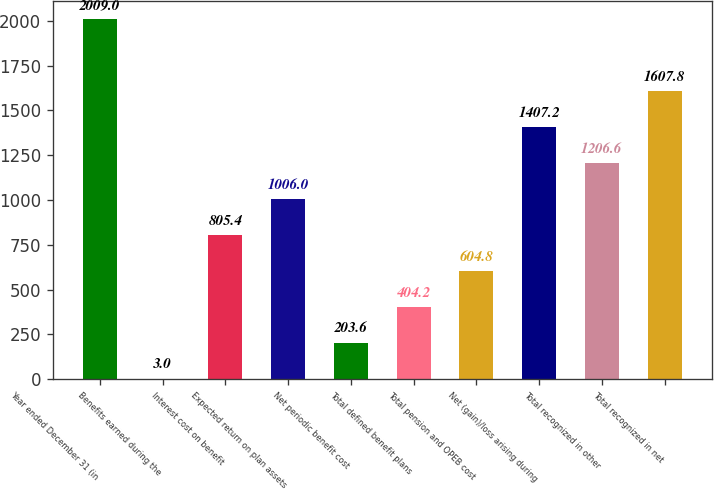Convert chart. <chart><loc_0><loc_0><loc_500><loc_500><bar_chart><fcel>Year ended December 31 (in<fcel>Benefits earned during the<fcel>Interest cost on benefit<fcel>Expected return on plan assets<fcel>Net periodic benefit cost<fcel>Total defined benefit plans<fcel>Total pension and OPEB cost<fcel>Net (gain)/loss arising during<fcel>Total recognized in other<fcel>Total recognized in net<nl><fcel>2009<fcel>3<fcel>805.4<fcel>1006<fcel>203.6<fcel>404.2<fcel>604.8<fcel>1407.2<fcel>1206.6<fcel>1607.8<nl></chart> 